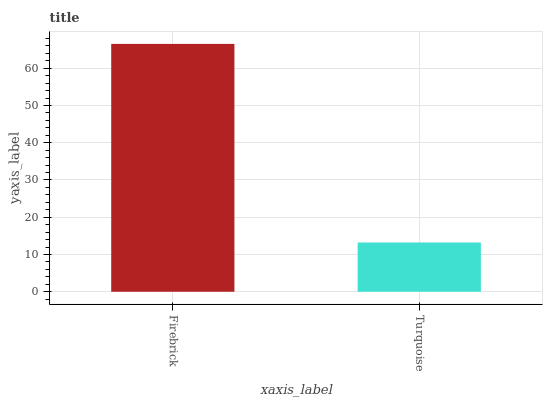Is Turquoise the minimum?
Answer yes or no. Yes. Is Firebrick the maximum?
Answer yes or no. Yes. Is Turquoise the maximum?
Answer yes or no. No. Is Firebrick greater than Turquoise?
Answer yes or no. Yes. Is Turquoise less than Firebrick?
Answer yes or no. Yes. Is Turquoise greater than Firebrick?
Answer yes or no. No. Is Firebrick less than Turquoise?
Answer yes or no. No. Is Firebrick the high median?
Answer yes or no. Yes. Is Turquoise the low median?
Answer yes or no. Yes. Is Turquoise the high median?
Answer yes or no. No. Is Firebrick the low median?
Answer yes or no. No. 